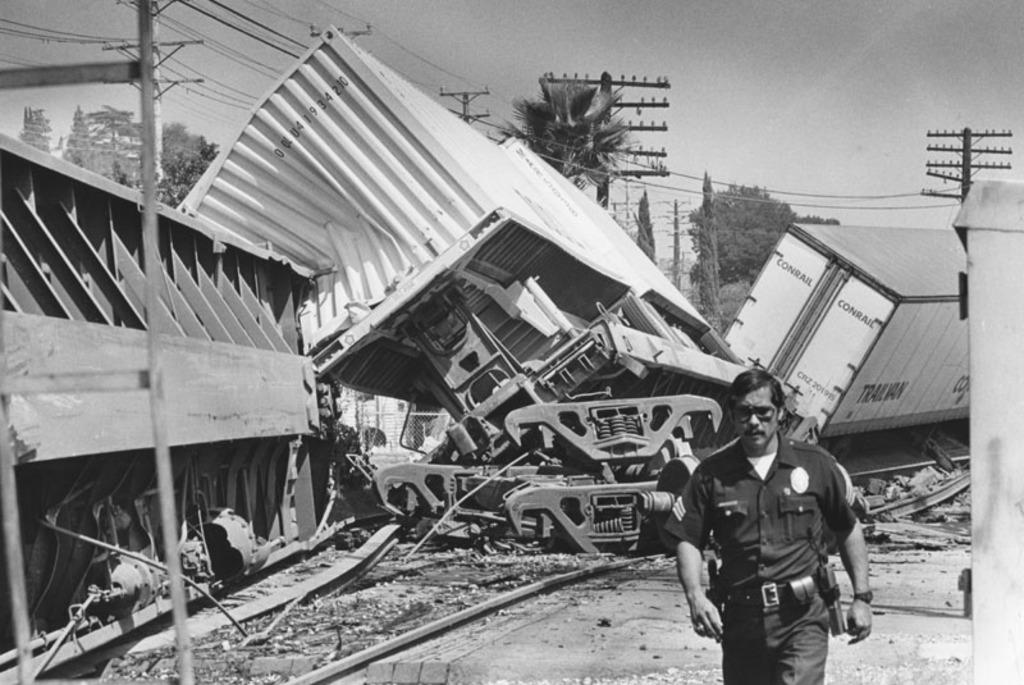What is the man in the image wearing? The man in the image is wearing a uniform. What can be seen in the background of the image? In the background of the image, there are containers, poles with wires, trees, and the sky. What is the color scheme of the image? The image is black and white in color. How many chickens are present in the image? There are no chickens present in the image. What type of vest is the man wearing in the image? The man in the image is not wearing a vest; he is wearing a uniform. 